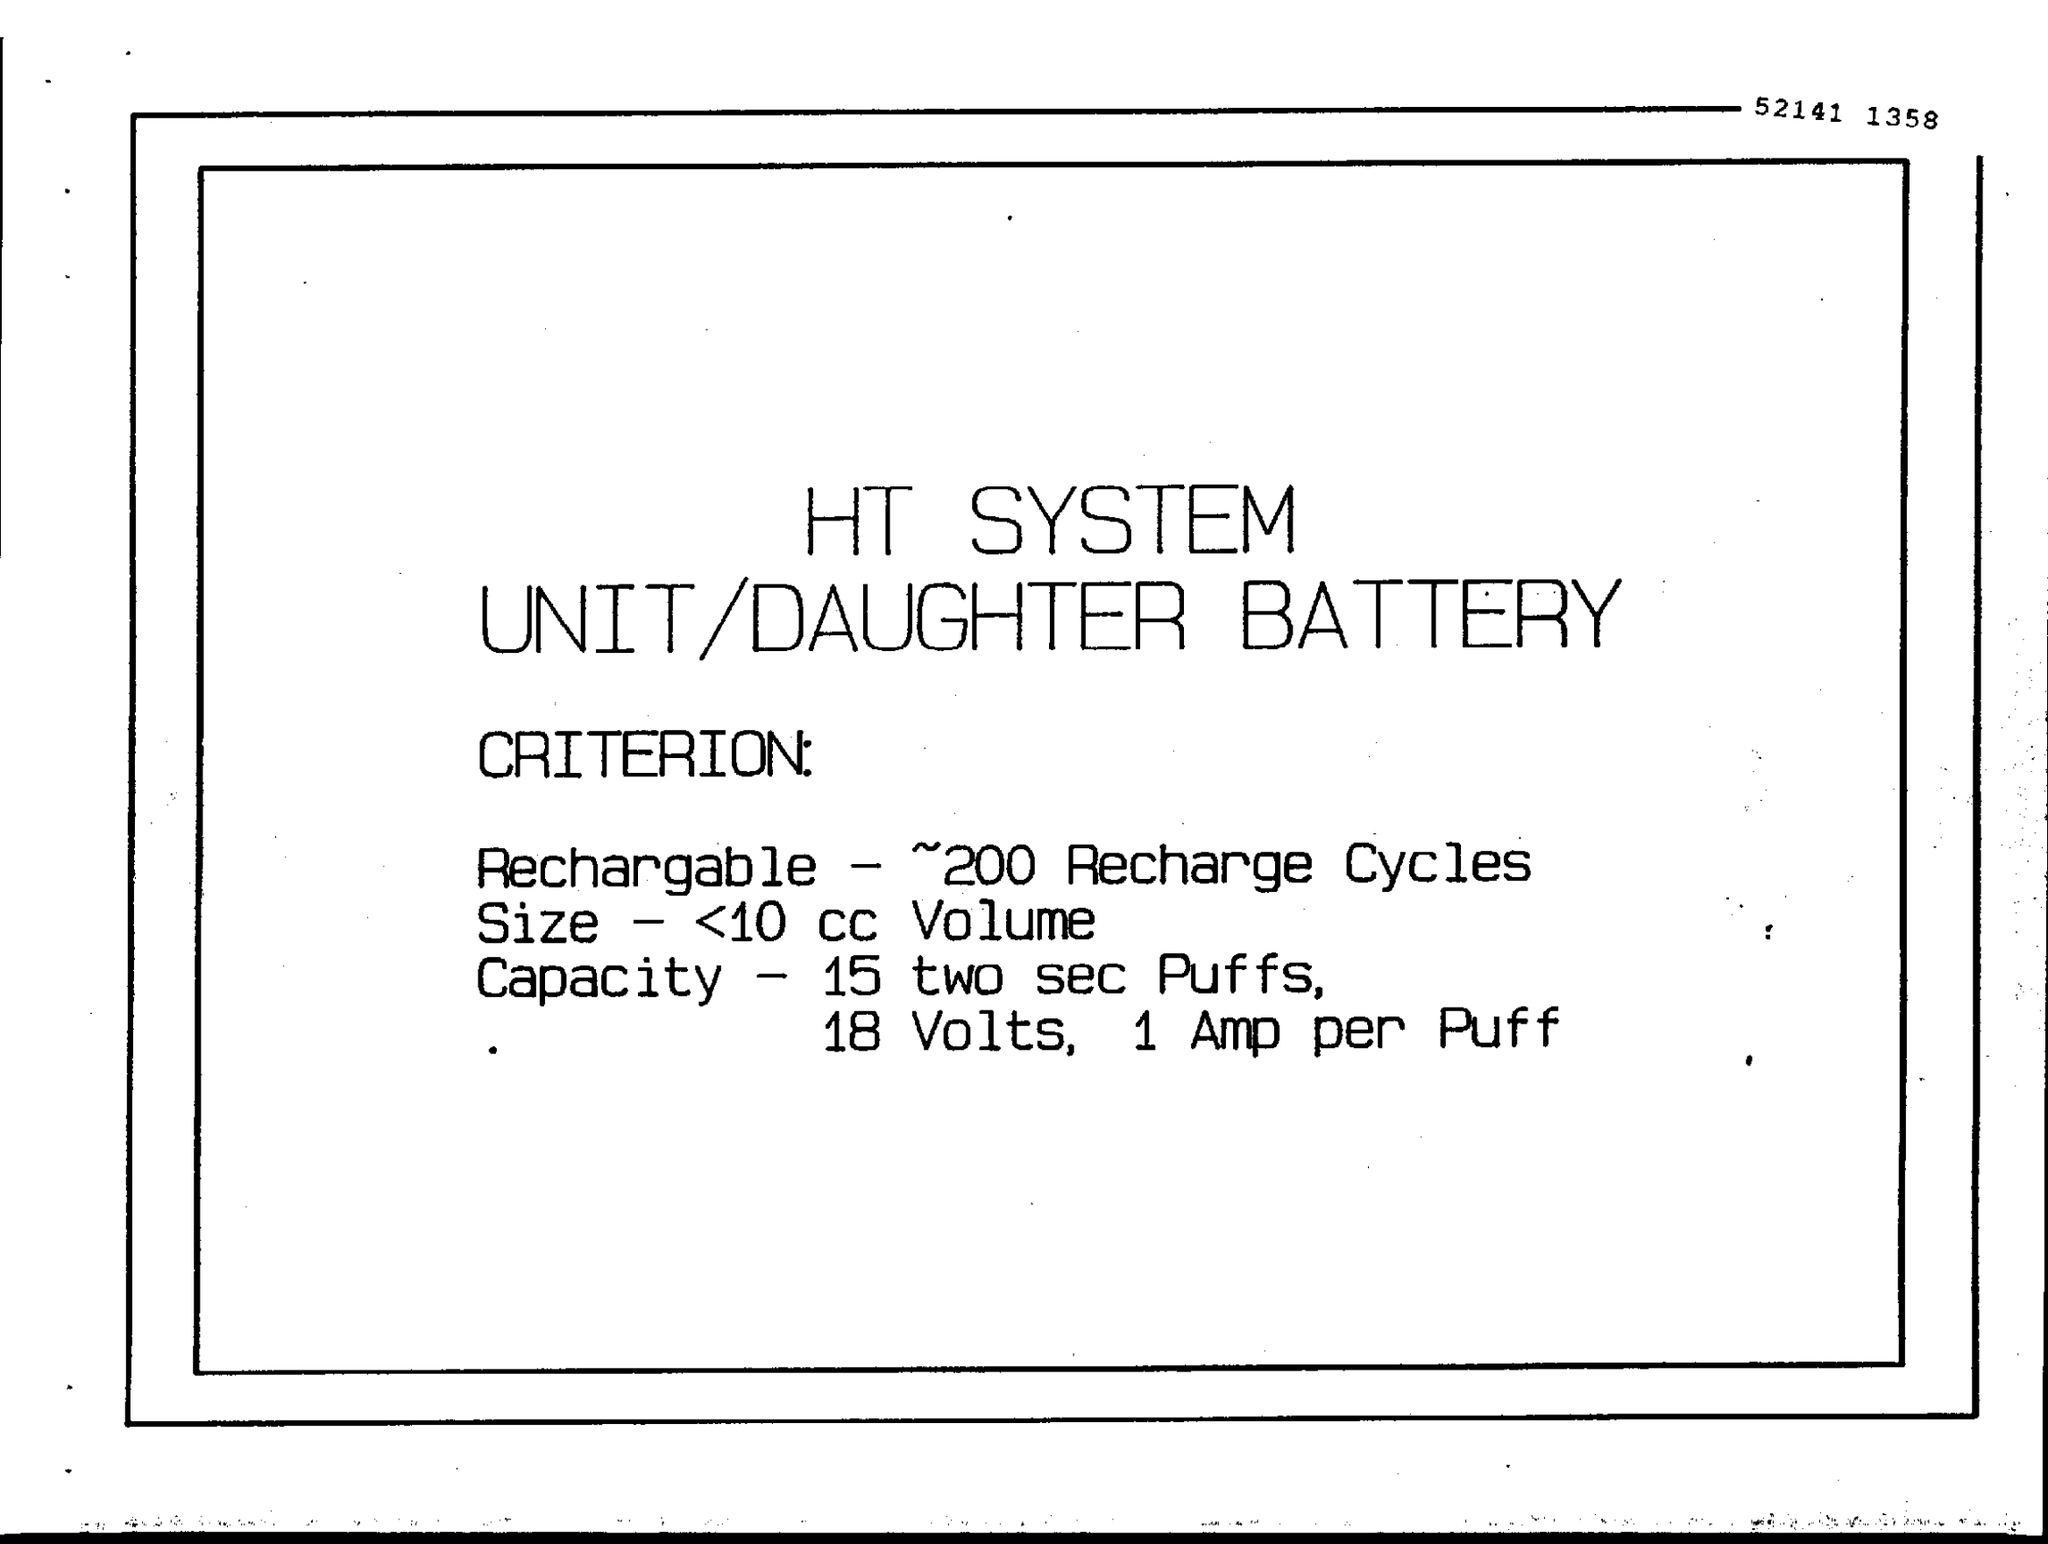Identify some key points in this picture. The battery size is less than or equal to 10 cc volume. The battery has a capacity to deliver 15 two-second puffs at 18 volts per puff with 1 amp per puff. 